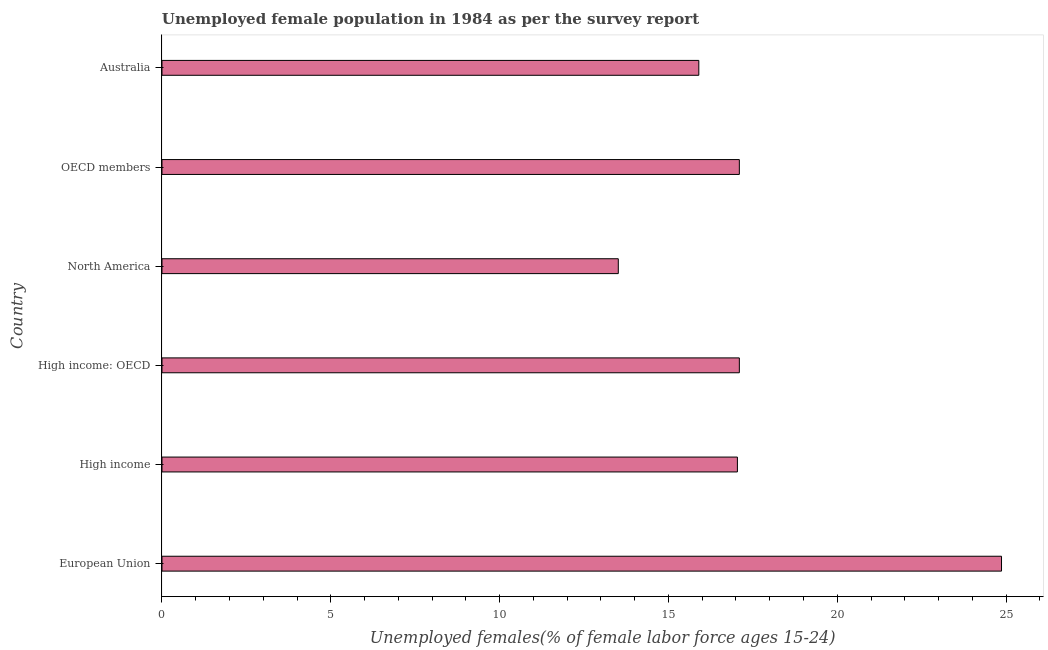Does the graph contain any zero values?
Provide a short and direct response. No. What is the title of the graph?
Provide a succinct answer. Unemployed female population in 1984 as per the survey report. What is the label or title of the X-axis?
Keep it short and to the point. Unemployed females(% of female labor force ages 15-24). What is the unemployed female youth in Australia?
Keep it short and to the point. 15.9. Across all countries, what is the maximum unemployed female youth?
Provide a succinct answer. 24.87. Across all countries, what is the minimum unemployed female youth?
Offer a terse response. 13.52. In which country was the unemployed female youth maximum?
Make the answer very short. European Union. What is the sum of the unemployed female youth?
Give a very brief answer. 105.52. What is the difference between the unemployed female youth in High income and North America?
Ensure brevity in your answer.  3.53. What is the average unemployed female youth per country?
Provide a succinct answer. 17.59. What is the median unemployed female youth?
Offer a very short reply. 17.07. What is the ratio of the unemployed female youth in European Union to that in High income: OECD?
Provide a short and direct response. 1.45. Is the difference between the unemployed female youth in High income and North America greater than the difference between any two countries?
Ensure brevity in your answer.  No. What is the difference between the highest and the second highest unemployed female youth?
Provide a succinct answer. 7.76. What is the difference between the highest and the lowest unemployed female youth?
Keep it short and to the point. 11.35. In how many countries, is the unemployed female youth greater than the average unemployed female youth taken over all countries?
Your response must be concise. 1. How many bars are there?
Provide a succinct answer. 6. Are all the bars in the graph horizontal?
Provide a short and direct response. Yes. How many countries are there in the graph?
Ensure brevity in your answer.  6. What is the difference between two consecutive major ticks on the X-axis?
Your answer should be compact. 5. Are the values on the major ticks of X-axis written in scientific E-notation?
Provide a short and direct response. No. What is the Unemployed females(% of female labor force ages 15-24) in European Union?
Your answer should be very brief. 24.87. What is the Unemployed females(% of female labor force ages 15-24) in High income?
Make the answer very short. 17.04. What is the Unemployed females(% of female labor force ages 15-24) of High income: OECD?
Keep it short and to the point. 17.1. What is the Unemployed females(% of female labor force ages 15-24) in North America?
Offer a very short reply. 13.52. What is the Unemployed females(% of female labor force ages 15-24) of OECD members?
Make the answer very short. 17.1. What is the Unemployed females(% of female labor force ages 15-24) of Australia?
Provide a short and direct response. 15.9. What is the difference between the Unemployed females(% of female labor force ages 15-24) in European Union and High income?
Provide a succinct answer. 7.82. What is the difference between the Unemployed females(% of female labor force ages 15-24) in European Union and High income: OECD?
Give a very brief answer. 7.77. What is the difference between the Unemployed females(% of female labor force ages 15-24) in European Union and North America?
Offer a terse response. 11.35. What is the difference between the Unemployed females(% of female labor force ages 15-24) in European Union and OECD members?
Your response must be concise. 7.77. What is the difference between the Unemployed females(% of female labor force ages 15-24) in European Union and Australia?
Make the answer very short. 8.97. What is the difference between the Unemployed females(% of female labor force ages 15-24) in High income and High income: OECD?
Your answer should be very brief. -0.06. What is the difference between the Unemployed females(% of female labor force ages 15-24) in High income and North America?
Make the answer very short. 3.53. What is the difference between the Unemployed females(% of female labor force ages 15-24) in High income and OECD members?
Ensure brevity in your answer.  -0.06. What is the difference between the Unemployed females(% of female labor force ages 15-24) in High income and Australia?
Offer a terse response. 1.14. What is the difference between the Unemployed females(% of female labor force ages 15-24) in High income: OECD and North America?
Ensure brevity in your answer.  3.59. What is the difference between the Unemployed females(% of female labor force ages 15-24) in High income: OECD and Australia?
Offer a very short reply. 1.2. What is the difference between the Unemployed females(% of female labor force ages 15-24) in North America and OECD members?
Your response must be concise. -3.59. What is the difference between the Unemployed females(% of female labor force ages 15-24) in North America and Australia?
Provide a succinct answer. -2.38. What is the difference between the Unemployed females(% of female labor force ages 15-24) in OECD members and Australia?
Provide a succinct answer. 1.2. What is the ratio of the Unemployed females(% of female labor force ages 15-24) in European Union to that in High income?
Offer a very short reply. 1.46. What is the ratio of the Unemployed females(% of female labor force ages 15-24) in European Union to that in High income: OECD?
Offer a very short reply. 1.45. What is the ratio of the Unemployed females(% of female labor force ages 15-24) in European Union to that in North America?
Your answer should be compact. 1.84. What is the ratio of the Unemployed females(% of female labor force ages 15-24) in European Union to that in OECD members?
Your answer should be compact. 1.45. What is the ratio of the Unemployed females(% of female labor force ages 15-24) in European Union to that in Australia?
Give a very brief answer. 1.56. What is the ratio of the Unemployed females(% of female labor force ages 15-24) in High income to that in North America?
Your answer should be very brief. 1.26. What is the ratio of the Unemployed females(% of female labor force ages 15-24) in High income to that in Australia?
Your response must be concise. 1.07. What is the ratio of the Unemployed females(% of female labor force ages 15-24) in High income: OECD to that in North America?
Offer a terse response. 1.26. What is the ratio of the Unemployed females(% of female labor force ages 15-24) in High income: OECD to that in OECD members?
Provide a succinct answer. 1. What is the ratio of the Unemployed females(% of female labor force ages 15-24) in High income: OECD to that in Australia?
Make the answer very short. 1.07. What is the ratio of the Unemployed females(% of female labor force ages 15-24) in North America to that in OECD members?
Make the answer very short. 0.79. What is the ratio of the Unemployed females(% of female labor force ages 15-24) in North America to that in Australia?
Your answer should be compact. 0.85. What is the ratio of the Unemployed females(% of female labor force ages 15-24) in OECD members to that in Australia?
Your answer should be very brief. 1.07. 